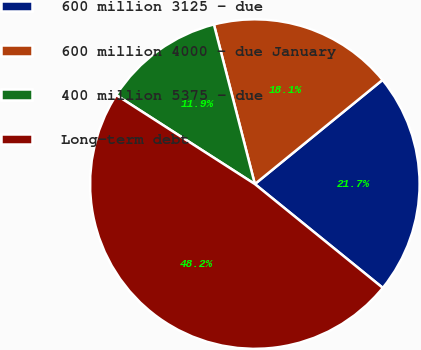<chart> <loc_0><loc_0><loc_500><loc_500><pie_chart><fcel>600 million 3125 - due<fcel>600 million 4000 - due January<fcel>400 million 5375 - due<fcel>Long-term debt<nl><fcel>21.74%<fcel>18.11%<fcel>11.92%<fcel>48.24%<nl></chart> 